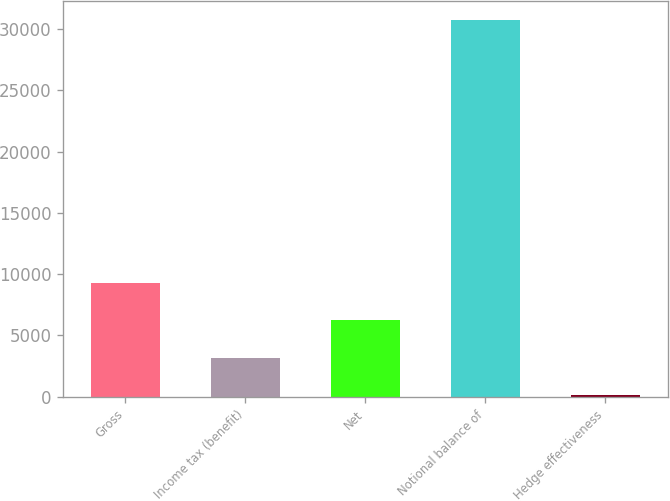<chart> <loc_0><loc_0><loc_500><loc_500><bar_chart><fcel>Gross<fcel>Income tax (benefit)<fcel>Net<fcel>Notional balance of<fcel>Hedge effectiveness<nl><fcel>9295<fcel>3165<fcel>6230<fcel>30750<fcel>100<nl></chart> 